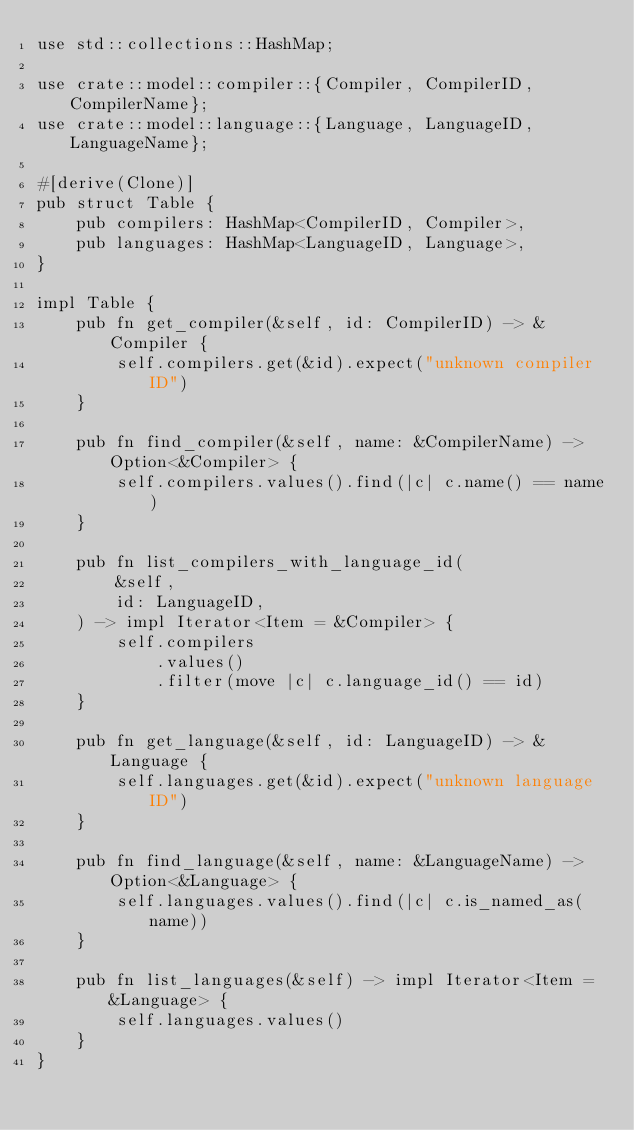<code> <loc_0><loc_0><loc_500><loc_500><_Rust_>use std::collections::HashMap;

use crate::model::compiler::{Compiler, CompilerID, CompilerName};
use crate::model::language::{Language, LanguageID, LanguageName};

#[derive(Clone)]
pub struct Table {
    pub compilers: HashMap<CompilerID, Compiler>,
    pub languages: HashMap<LanguageID, Language>,
}

impl Table {
    pub fn get_compiler(&self, id: CompilerID) -> &Compiler {
        self.compilers.get(&id).expect("unknown compiler ID")
    }

    pub fn find_compiler(&self, name: &CompilerName) -> Option<&Compiler> {
        self.compilers.values().find(|c| c.name() == name)
    }

    pub fn list_compilers_with_language_id(
        &self,
        id: LanguageID,
    ) -> impl Iterator<Item = &Compiler> {
        self.compilers
            .values()
            .filter(move |c| c.language_id() == id)
    }

    pub fn get_language(&self, id: LanguageID) -> &Language {
        self.languages.get(&id).expect("unknown language ID")
    }

    pub fn find_language(&self, name: &LanguageName) -> Option<&Language> {
        self.languages.values().find(|c| c.is_named_as(name))
    }

    pub fn list_languages(&self) -> impl Iterator<Item = &Language> {
        self.languages.values()
    }
}
</code> 